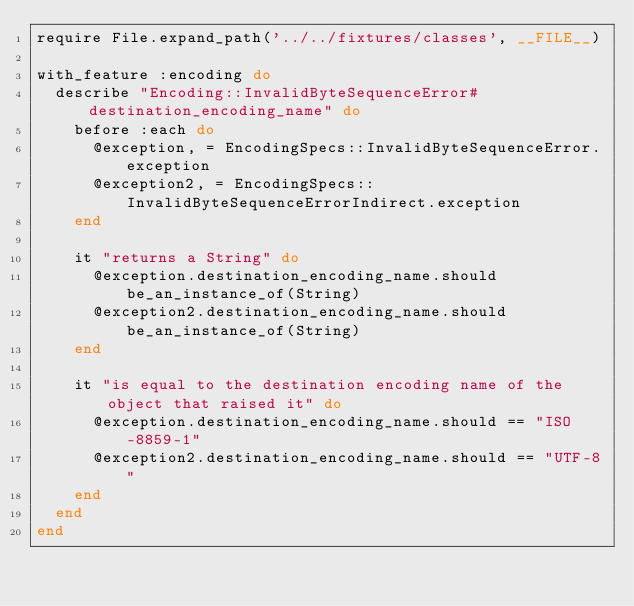<code> <loc_0><loc_0><loc_500><loc_500><_Ruby_>require File.expand_path('../../fixtures/classes', __FILE__)

with_feature :encoding do
  describe "Encoding::InvalidByteSequenceError#destination_encoding_name" do
    before :each do
      @exception, = EncodingSpecs::InvalidByteSequenceError.exception
      @exception2, = EncodingSpecs::InvalidByteSequenceErrorIndirect.exception
    end

    it "returns a String" do
      @exception.destination_encoding_name.should be_an_instance_of(String)
      @exception2.destination_encoding_name.should be_an_instance_of(String)
    end

    it "is equal to the destination encoding name of the object that raised it" do
      @exception.destination_encoding_name.should == "ISO-8859-1"
      @exception2.destination_encoding_name.should == "UTF-8"
    end
  end
end
</code> 